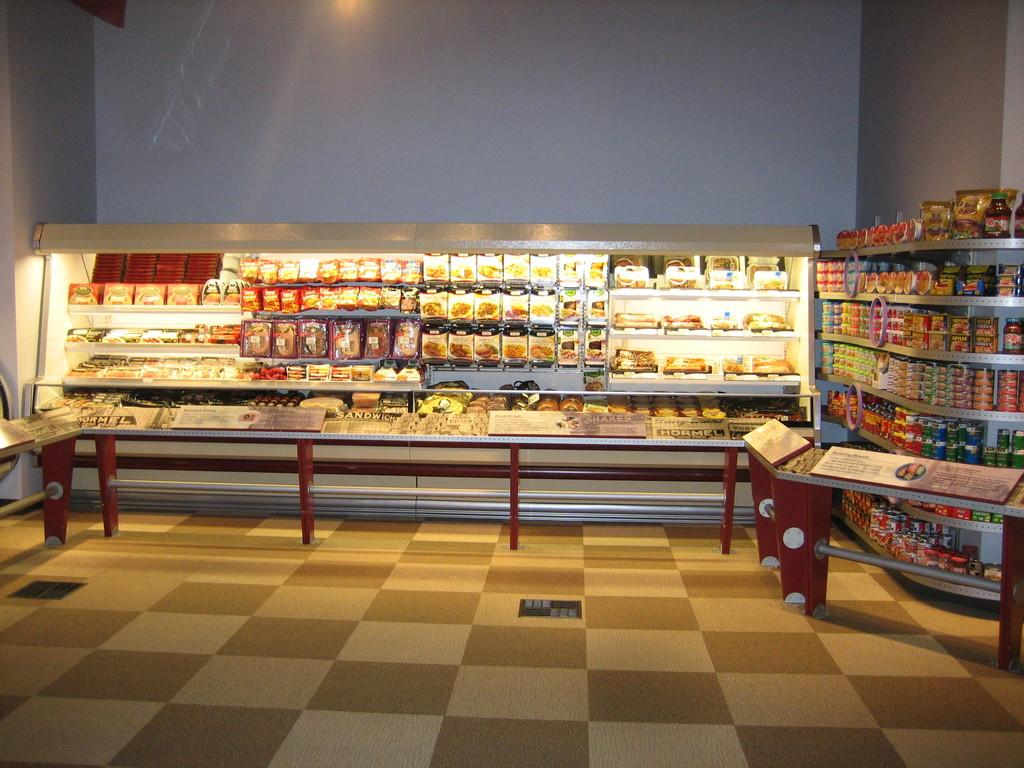What objects are placed on tables in the image? There are boards on tables in the image. Where else can boards be found in the image? Boards can also be found on the floor in the image. What type of containers are present in the image? There are bottles in the image. What is the storage method for some objects in the image? Objects are stored in racks in the image. What can be seen in the background of the image? There is a wall visible in the background of the image. What type of fear is depicted on the wall in the image? There is no fear depicted on the wall in the image; it is a plain wall visible in the background. 